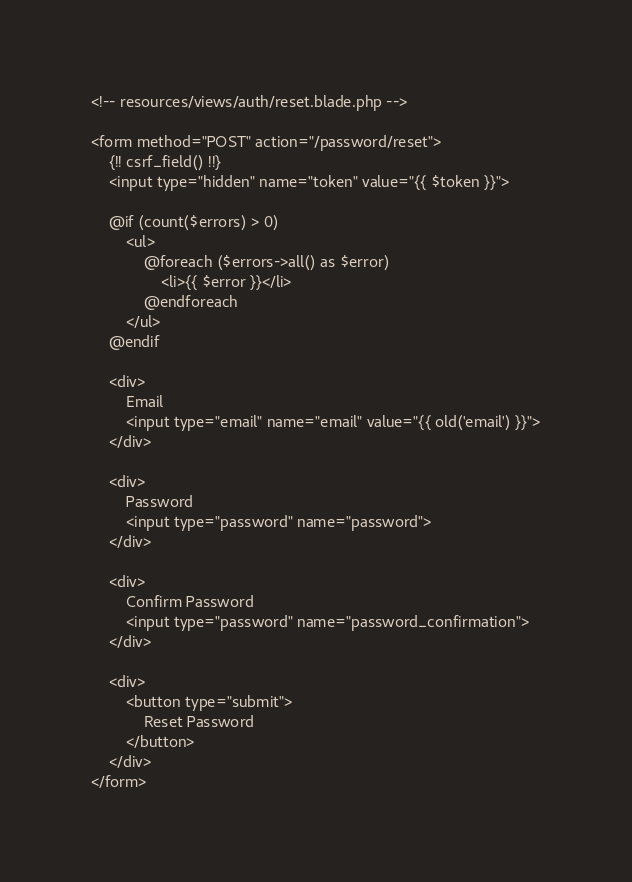<code> <loc_0><loc_0><loc_500><loc_500><_PHP_><!-- resources/views/auth/reset.blade.php -->

<form method="POST" action="/password/reset">
    {!! csrf_field() !!}
    <input type="hidden" name="token" value="{{ $token }}">

    @if (count($errors) > 0)
        <ul>
            @foreach ($errors->all() as $error)
                <li>{{ $error }}</li>
            @endforeach
        </ul>
    @endif

    <div>
        Email
        <input type="email" name="email" value="{{ old('email') }}">
    </div>

    <div>
        Password
        <input type="password" name="password">
    </div>

    <div>
        Confirm Password
        <input type="password" name="password_confirmation">
    </div>

    <div>
        <button type="submit">
            Reset Password
        </button>
    </div>
</form>
</code> 